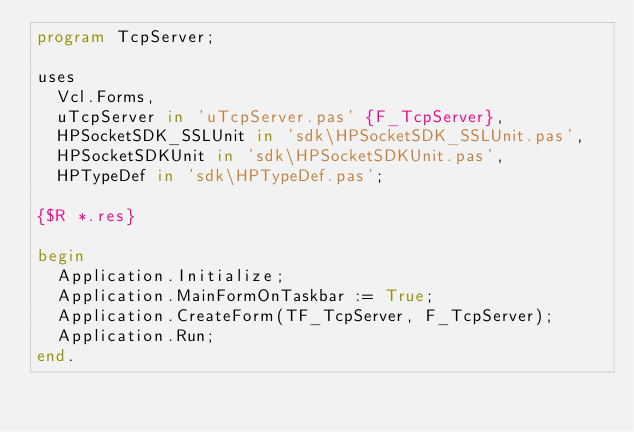Convert code to text. <code><loc_0><loc_0><loc_500><loc_500><_Pascal_>program TcpServer;

uses
  Vcl.Forms,
  uTcpServer in 'uTcpServer.pas' {F_TcpServer},
  HPSocketSDK_SSLUnit in 'sdk\HPSocketSDK_SSLUnit.pas',
  HPSocketSDKUnit in 'sdk\HPSocketSDKUnit.pas',
  HPTypeDef in 'sdk\HPTypeDef.pas';

{$R *.res}

begin
  Application.Initialize;
  Application.MainFormOnTaskbar := True;
  Application.CreateForm(TF_TcpServer, F_TcpServer);
  Application.Run;
end.
</code> 